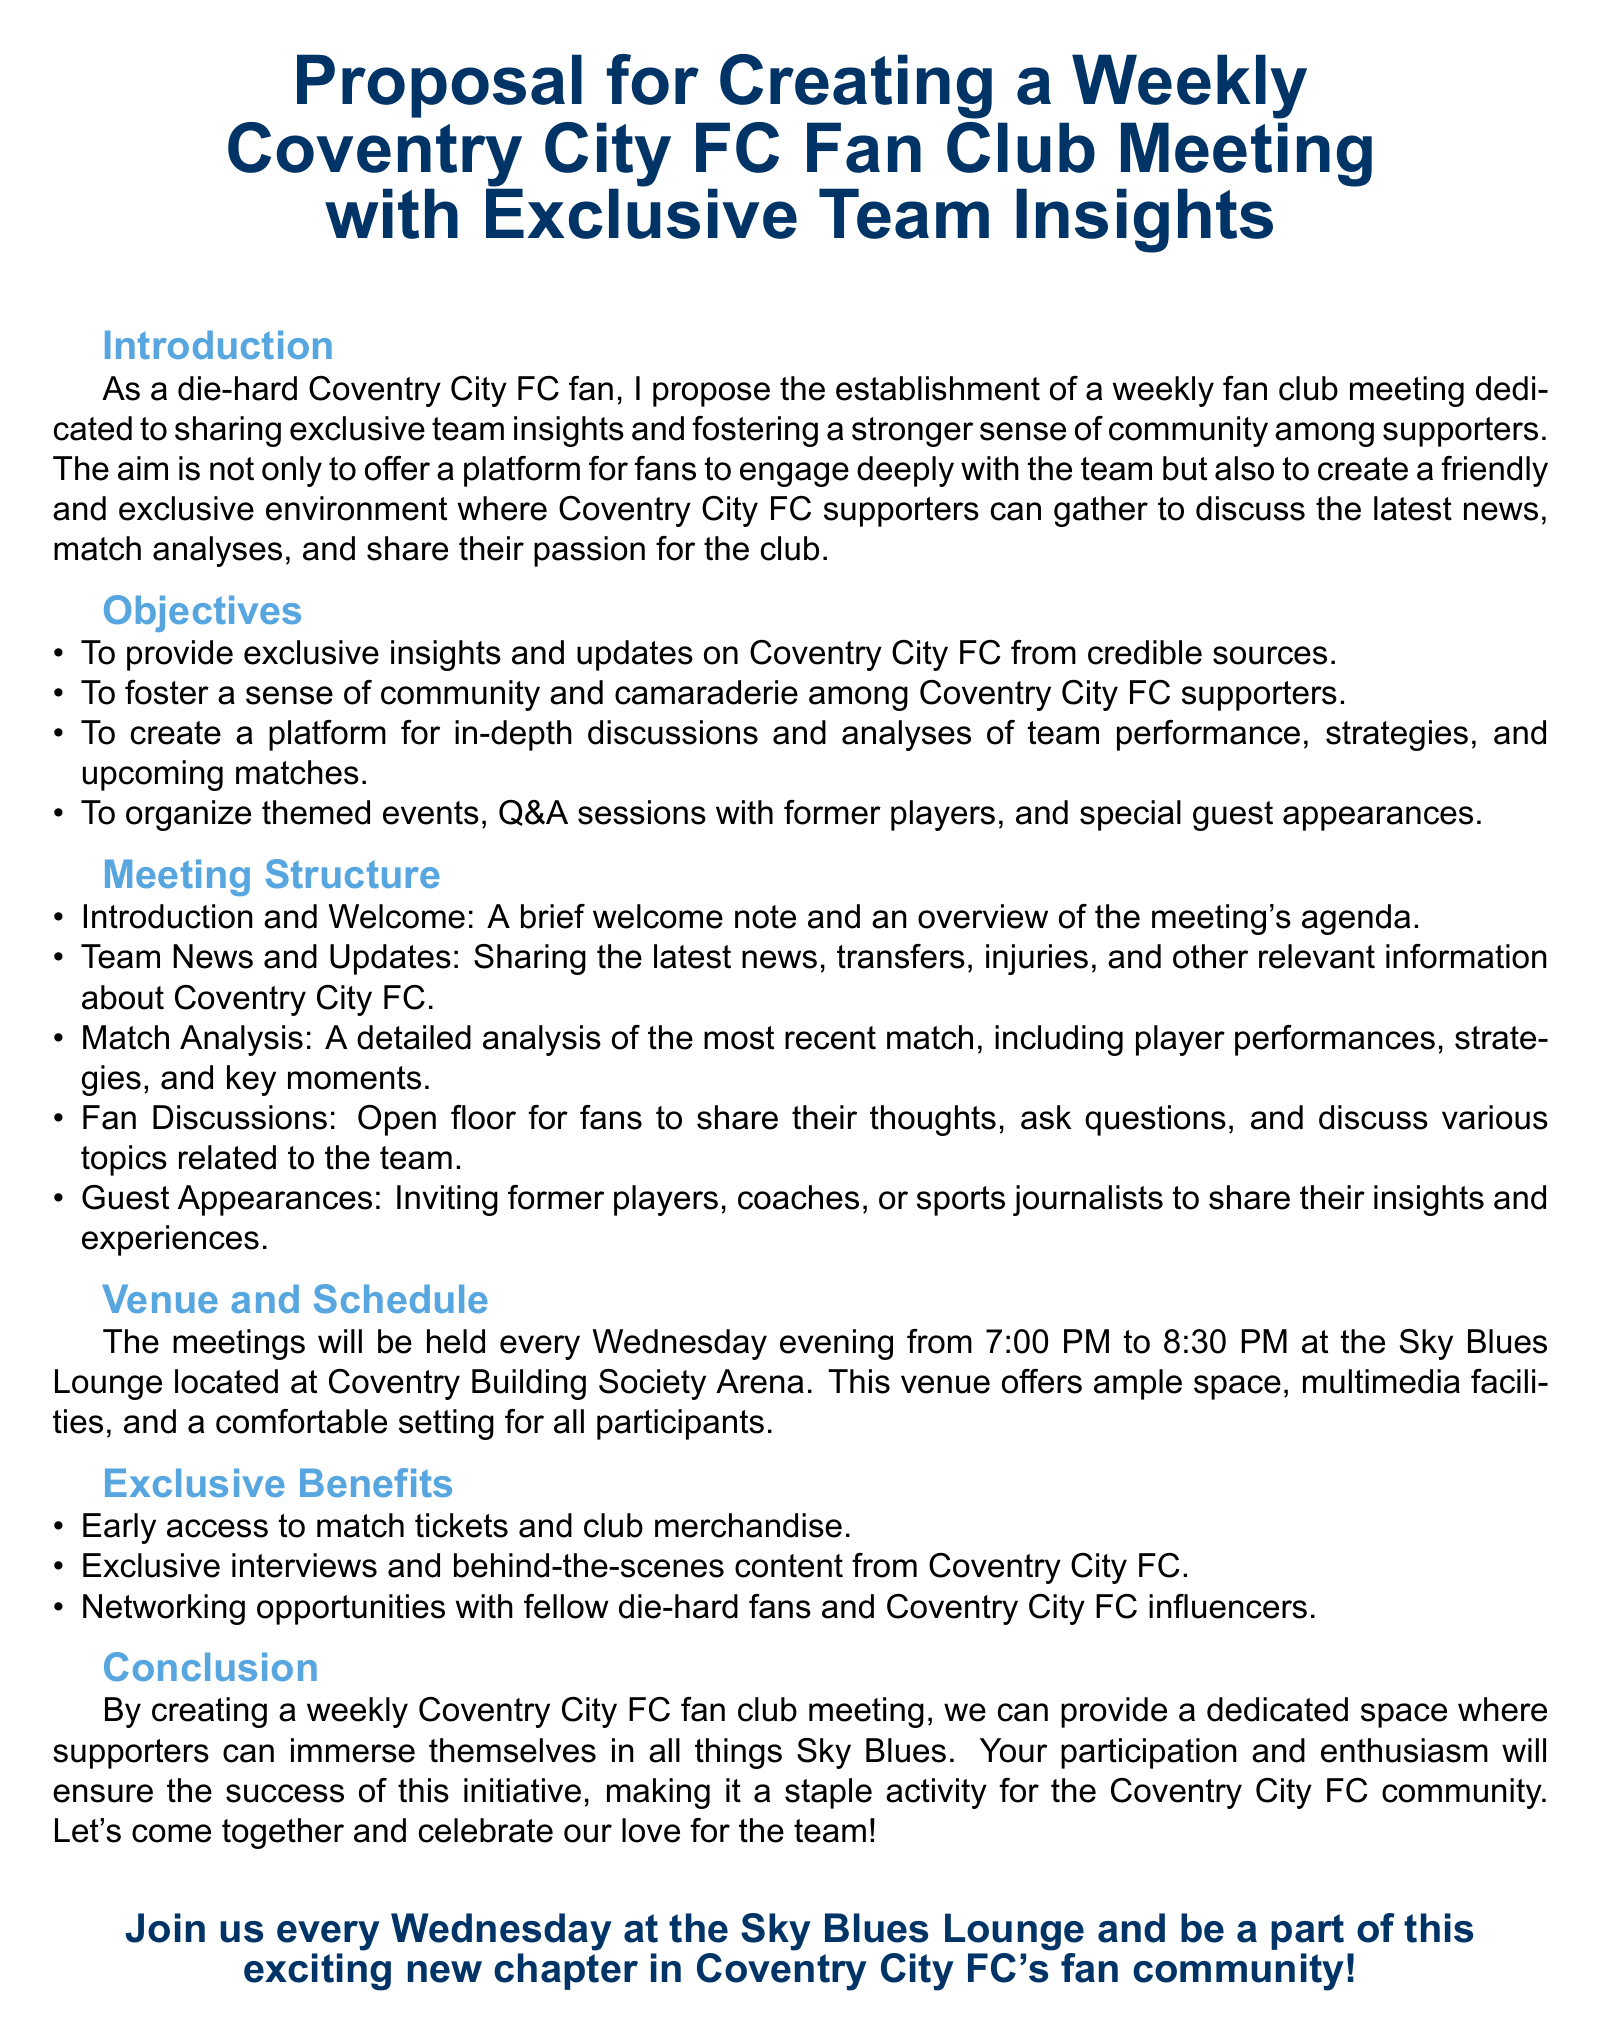What is the title of the proposal? The title of the proposal is stated at the beginning of the document.
Answer: Proposal for Creating a Weekly Coventry City FC Fan Club Meeting with Exclusive Team Insights What day of the week are the meetings scheduled? The meetings schedule is outlined in the "Venue and Schedule" section of the document.
Answer: Wednesday What time do the meetings start? The starting time is mentioned in the "Venue and Schedule" section.
Answer: 7:00 PM What is one of the objectives of the fan club meetings? The objectives list several goals for the meetings, mentioning one specific goal is sufficient.
Answer: To provide exclusive insights and updates on Coventry City FC from credible sources Where will the meetings be held? The venue for the meetings is provided in the "Venue and Schedule" section.
Answer: Sky Blues Lounge Which type of events are mentioned as part of the meeting structure? The meeting structure includes various components, and one specific format is acceptable as an answer.
Answer: Guest Appearances What benefit includes networking opportunities? The exclusive benefits section outlines perks for participants, mentioning one specific benefit is enough.
Answer: Networking opportunities with fellow die-hard fans and Coventry City FC influencers How long will each meeting last? The duration is specified in the "Venue and Schedule" section.
Answer: 1.5 hours 